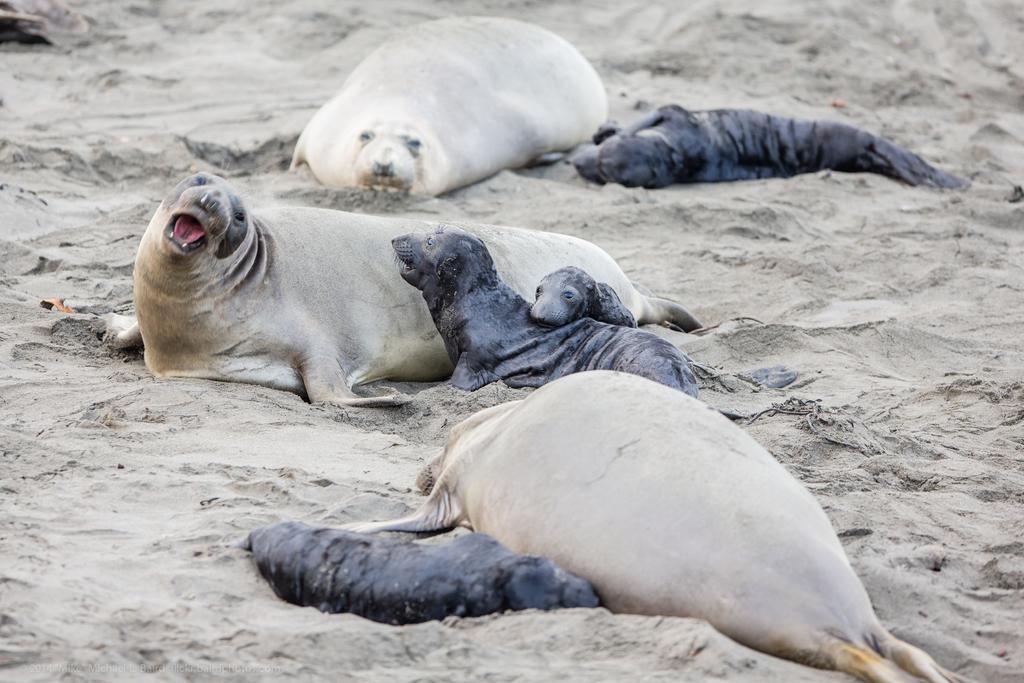In one or two sentences, can you explain what this image depicts? In this picture we can see seals on the ground and we can see sand in the background. 